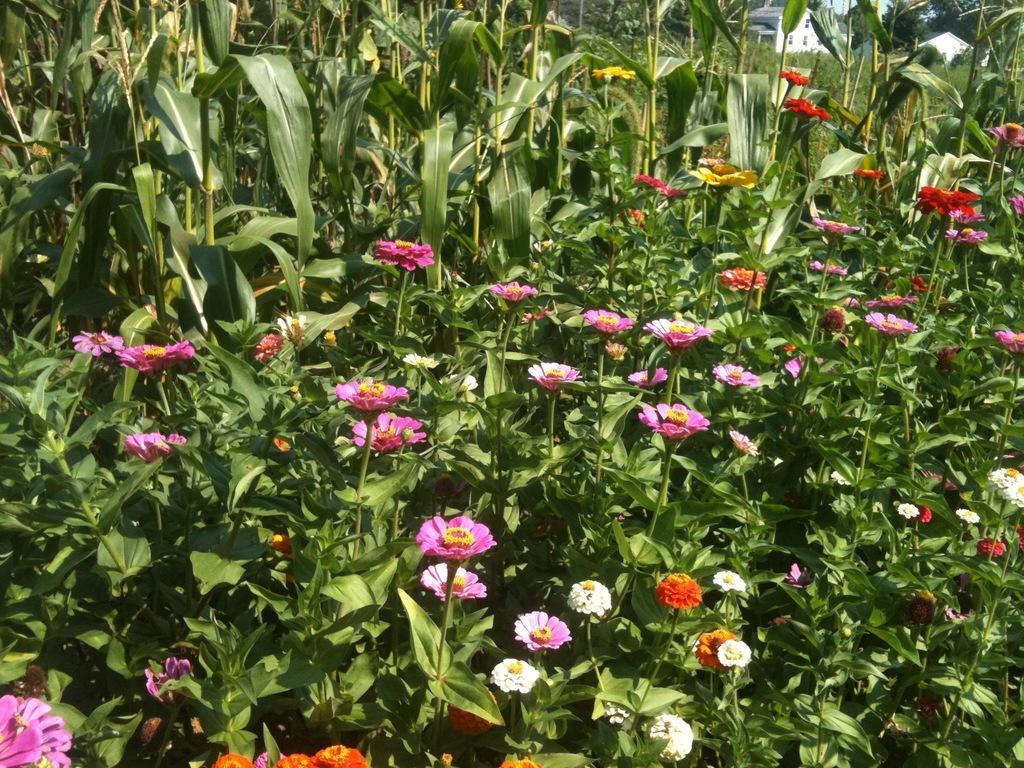Please provide a concise description of this image. In this picture I see number of planets and I see flowers which are of pink, orange, white and red in color. In the background I see a house on the top right. 